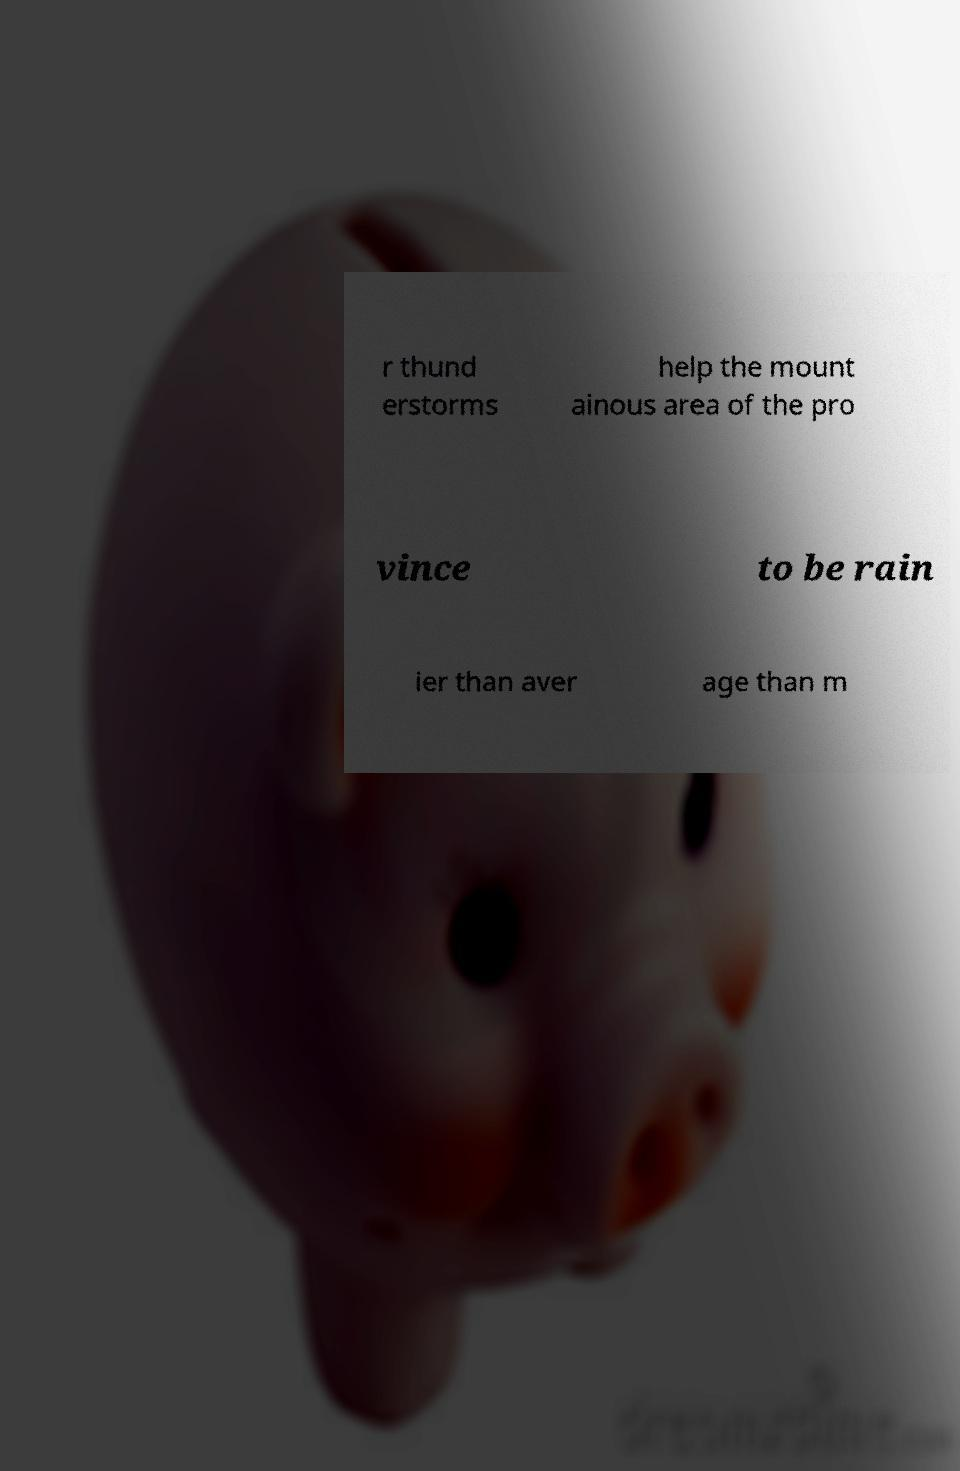What messages or text are displayed in this image? I need them in a readable, typed format. r thund erstorms help the mount ainous area of the pro vince to be rain ier than aver age than m 